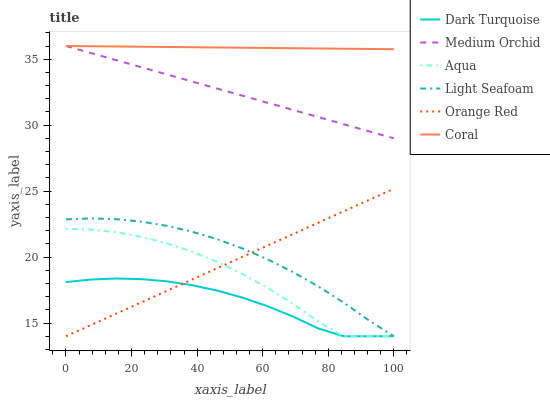Does Dark Turquoise have the minimum area under the curve?
Answer yes or no. Yes. Does Coral have the maximum area under the curve?
Answer yes or no. Yes. Does Medium Orchid have the minimum area under the curve?
Answer yes or no. No. Does Medium Orchid have the maximum area under the curve?
Answer yes or no. No. Is Orange Red the smoothest?
Answer yes or no. Yes. Is Aqua the roughest?
Answer yes or no. Yes. Is Coral the smoothest?
Answer yes or no. No. Is Coral the roughest?
Answer yes or no. No. Does Medium Orchid have the lowest value?
Answer yes or no. No. Does Medium Orchid have the highest value?
Answer yes or no. Yes. Does Aqua have the highest value?
Answer yes or no. No. Is Aqua less than Medium Orchid?
Answer yes or no. Yes. Is Medium Orchid greater than Orange Red?
Answer yes or no. Yes. Does Medium Orchid intersect Coral?
Answer yes or no. Yes. Is Medium Orchid less than Coral?
Answer yes or no. No. Is Medium Orchid greater than Coral?
Answer yes or no. No. Does Aqua intersect Medium Orchid?
Answer yes or no. No. 